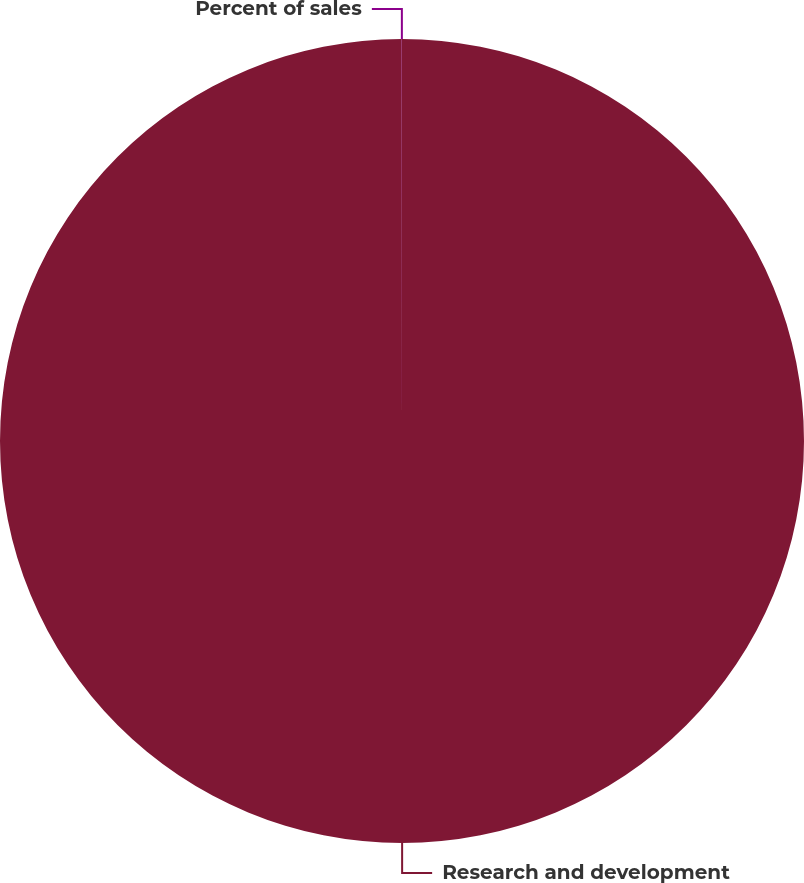Convert chart. <chart><loc_0><loc_0><loc_500><loc_500><pie_chart><fcel>Research and development<fcel>Percent of sales<nl><fcel>99.99%<fcel>0.01%<nl></chart> 